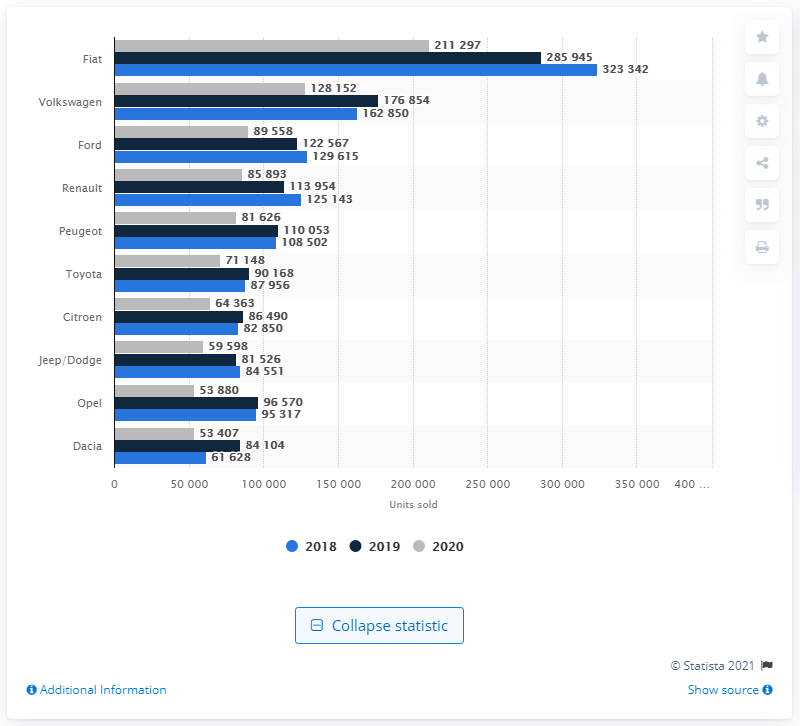Highlight a few significant elements in this photo. In 2020, Fiat was the automaker that sold the most cars in Italy. 